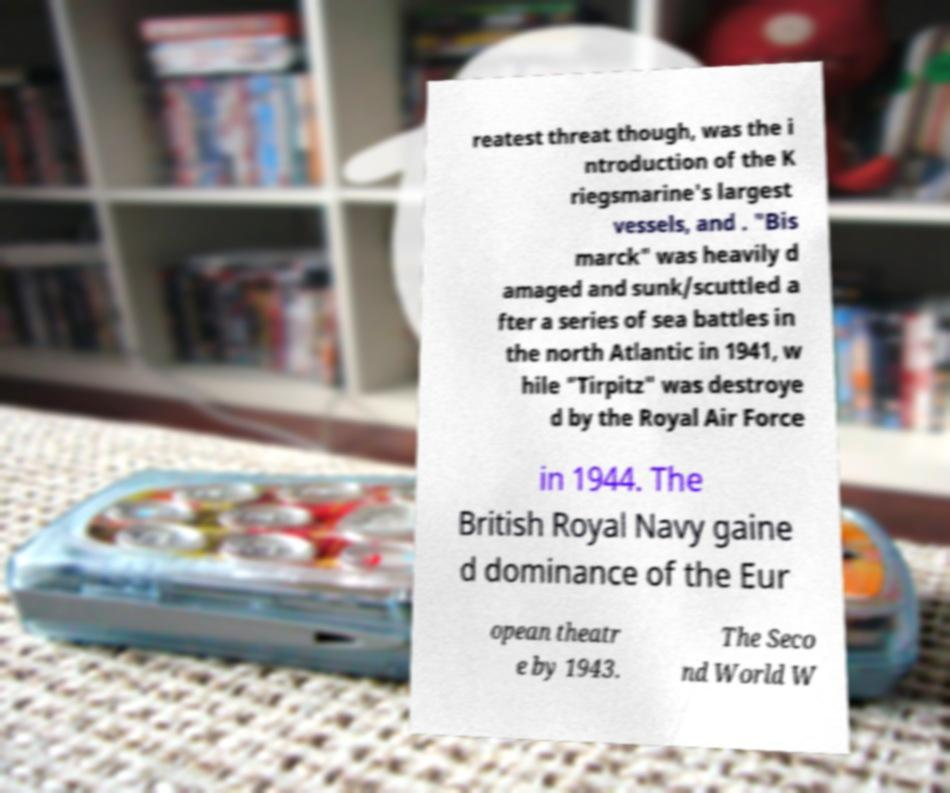What messages or text are displayed in this image? I need them in a readable, typed format. reatest threat though, was the i ntroduction of the K riegsmarine's largest vessels, and . "Bis marck" was heavily d amaged and sunk/scuttled a fter a series of sea battles in the north Atlantic in 1941, w hile "Tirpitz" was destroye d by the Royal Air Force in 1944. The British Royal Navy gaine d dominance of the Eur opean theatr e by 1943. The Seco nd World W 